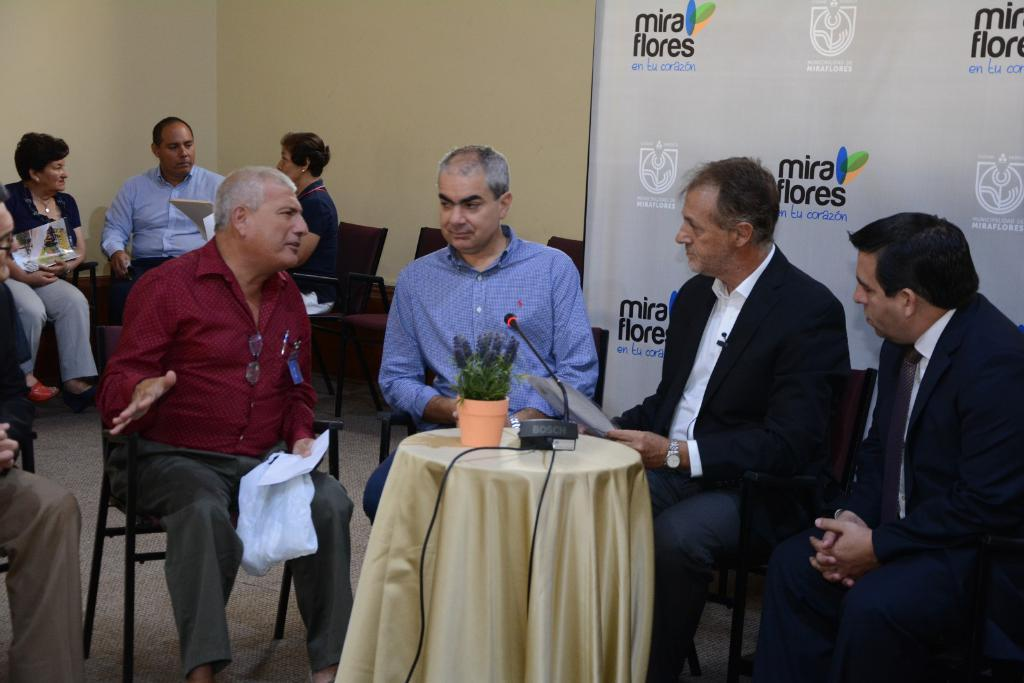What is happening in the image? A: There are people sitting around a table in the image. What is on the table besides the people? There is a plant and a mic on the table. Are there any other people visible in the image? Yes, there are other people to the side of the table. What time is displayed on the clock in the image? There is no clock present in the image. How many pages are visible in the image? There are no pages visible in the image. 